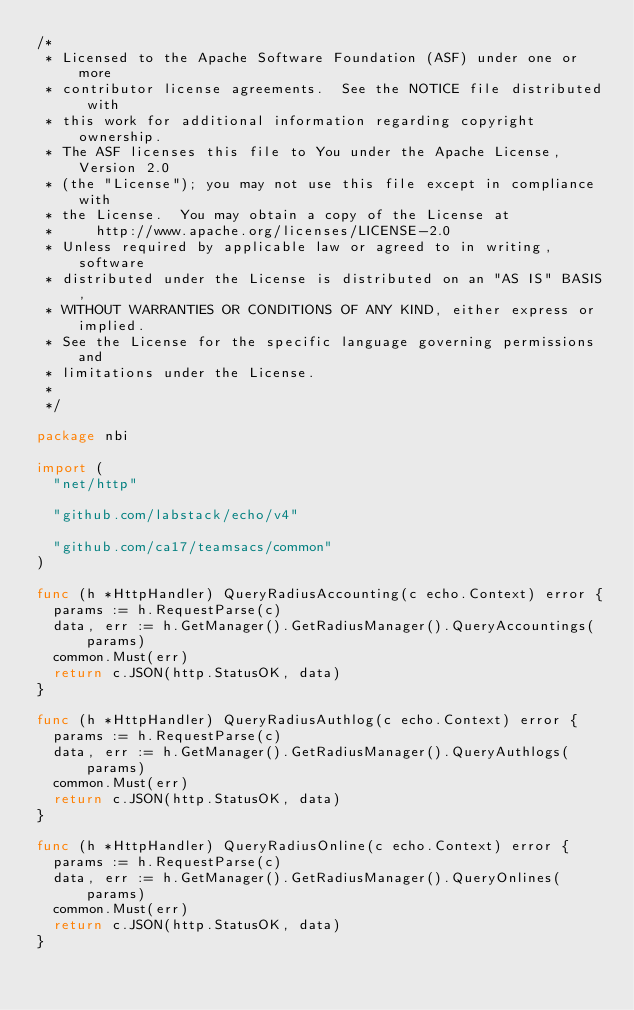Convert code to text. <code><loc_0><loc_0><loc_500><loc_500><_Go_>/*
 * Licensed to the Apache Software Foundation (ASF) under one or more
 * contributor license agreements.  See the NOTICE file distributed with
 * this work for additional information regarding copyright ownership.
 * The ASF licenses this file to You under the Apache License, Version 2.0
 * (the "License"); you may not use this file except in compliance with
 * the License.  You may obtain a copy of the License at
 *     http://www.apache.org/licenses/LICENSE-2.0
 * Unless required by applicable law or agreed to in writing, software
 * distributed under the License is distributed on an "AS IS" BASIS,
 * WITHOUT WARRANTIES OR CONDITIONS OF ANY KIND, either express or implied.
 * See the License for the specific language governing permissions and
 * limitations under the License.
 *
 */

package nbi

import (
	"net/http"

	"github.com/labstack/echo/v4"

	"github.com/ca17/teamsacs/common"
)

func (h *HttpHandler) QueryRadiusAccounting(c echo.Context) error {
	params := h.RequestParse(c)
	data, err := h.GetManager().GetRadiusManager().QueryAccountings(params)
	common.Must(err)
	return c.JSON(http.StatusOK, data)
}

func (h *HttpHandler) QueryRadiusAuthlog(c echo.Context) error {
	params := h.RequestParse(c)
	data, err := h.GetManager().GetRadiusManager().QueryAuthlogs(params)
	common.Must(err)
	return c.JSON(http.StatusOK, data)
}

func (h *HttpHandler) QueryRadiusOnline(c echo.Context) error {
	params := h.RequestParse(c)
	data, err := h.GetManager().GetRadiusManager().QueryOnlines(params)
	common.Must(err)
	return c.JSON(http.StatusOK, data)
}

</code> 